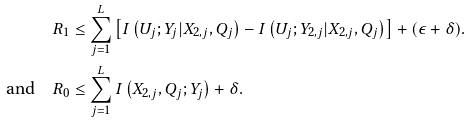<formula> <loc_0><loc_0><loc_500><loc_500>R _ { 1 } & \leq \sum _ { j = 1 } ^ { L } \left [ I \left ( U _ { j } ; Y _ { j } | X _ { 2 , j } , Q _ { j } \right ) - I \left ( U _ { j } ; Y _ { 2 , j } | X _ { 2 , j } , Q _ { j } \right ) \right ] + ( \epsilon + \delta ) . \\ \text {and} \quad R _ { 0 } & \leq \sum _ { j = 1 } ^ { L } I \left ( X _ { 2 , j } , Q _ { j } ; Y _ { j } \right ) + \delta .</formula> 